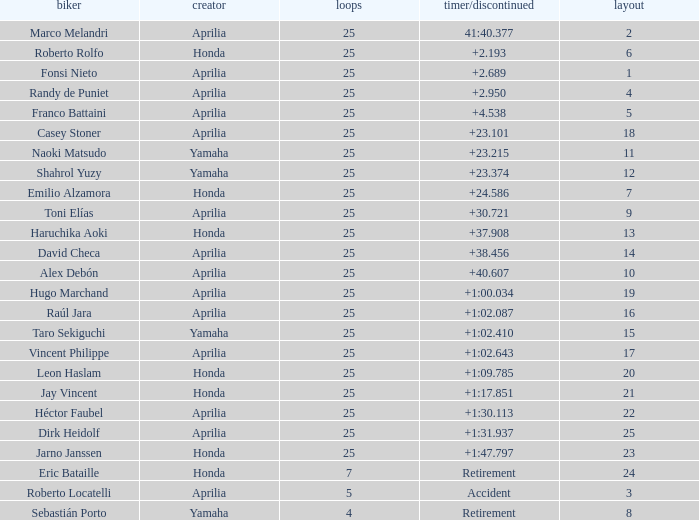Which Grid has Laps of 25, and a Manufacturer of honda, and a Time/Retired of +1:47.797? 23.0. 